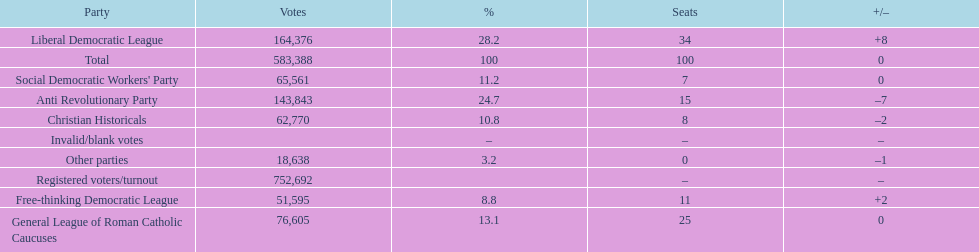After the election, how many seats did the liberal democratic league win? 34. 